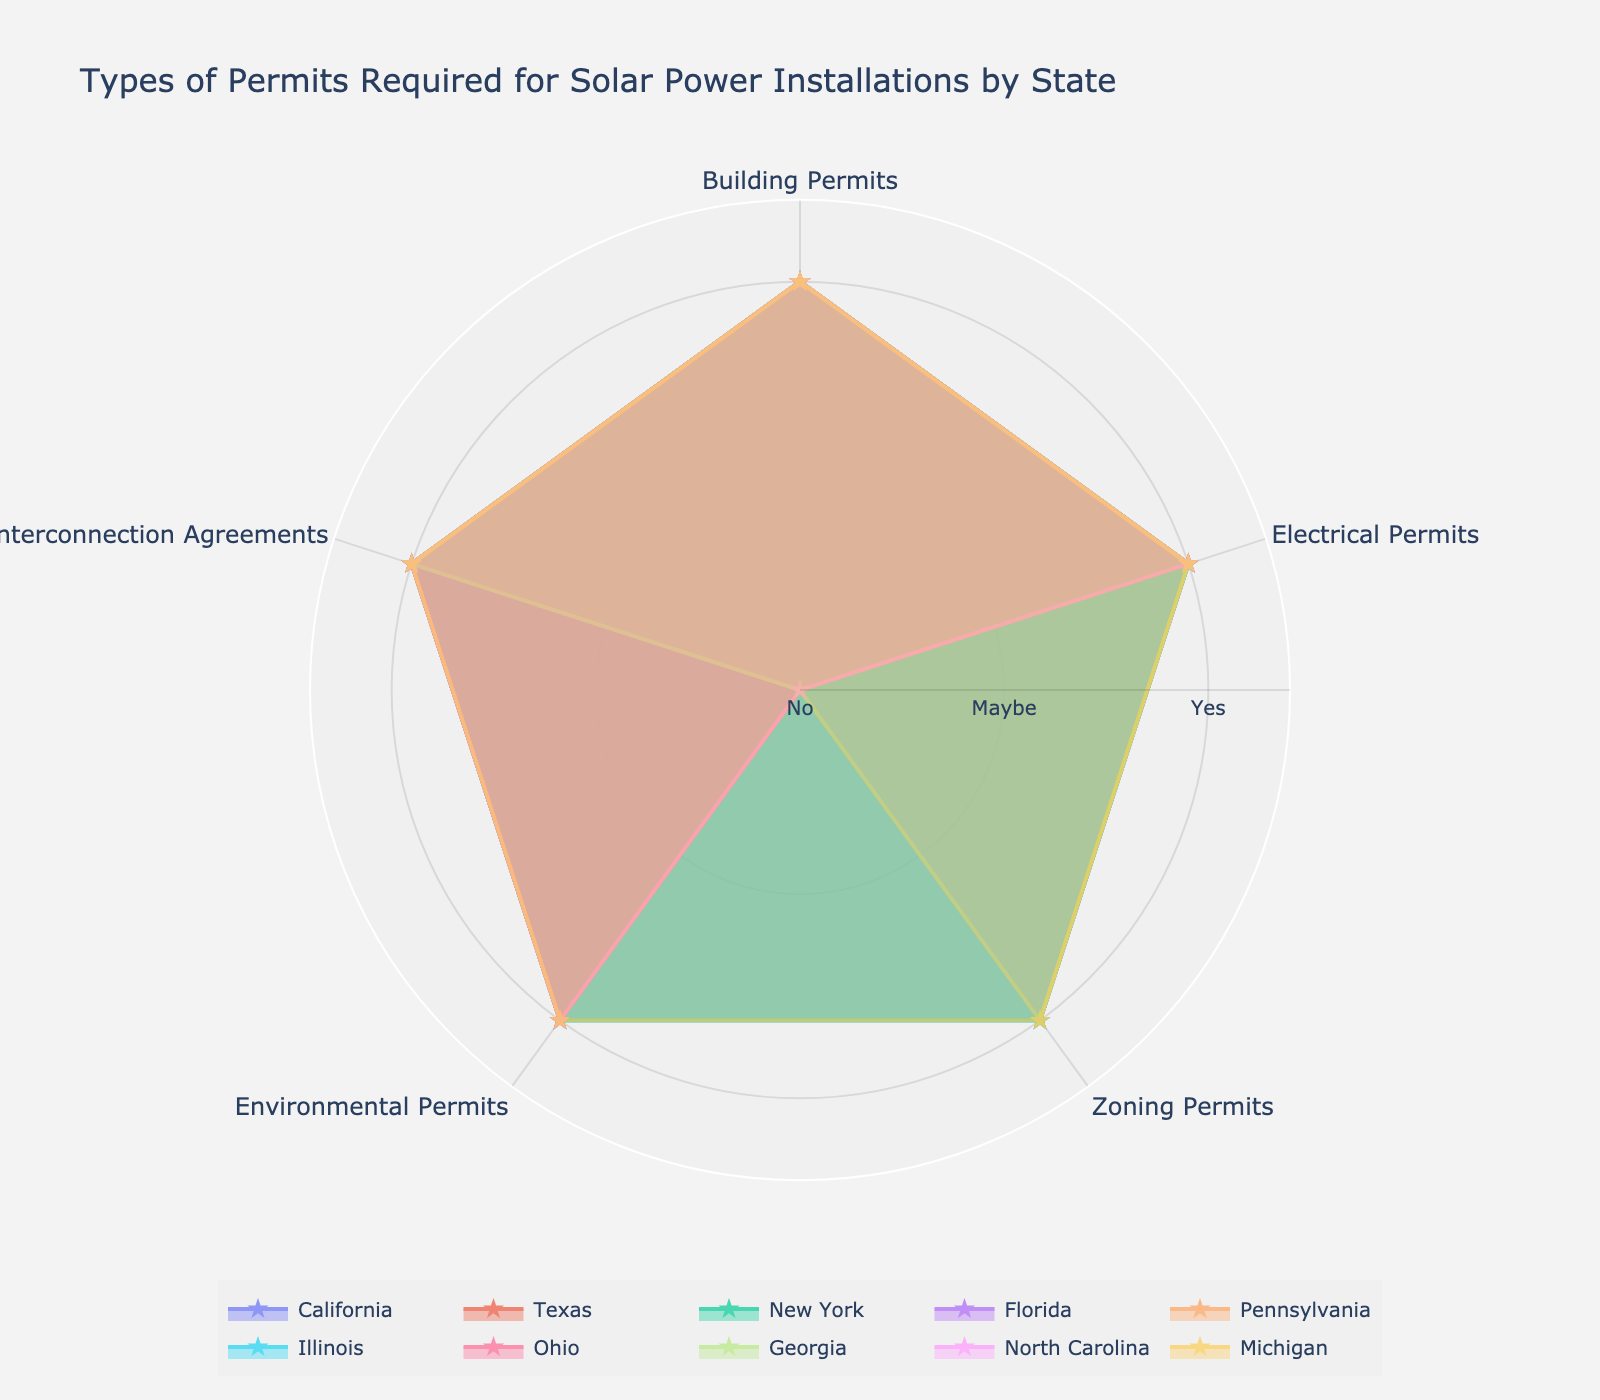What's the title of the chart? The title is the first element of a figure that summarizes what the chart is about, typically found at the top.
Answer: Types of Permits Required for Solar Power Installations by State What color are the grid lines in the chart? Grid lines are the faint lines behind the radar plot that guide the eyes to the data points. They are typically in a distinct but soft color.
Answer: Light gray Which state does not require a Zoning Permit for solar power installations? To determine this, look for states with a 0 value (indicating 'No') in the Zoning Permits portion of the radar chart.
Answer: Texas How many states have all five types of permits required? Identify states that have all entries filled in with a 1 in all five permit categories.
Answer: Six states Which states require Environmental Permits for solar power installations? Find states with a 1 value in the Environmental Permits section of the radar chart.
Answer: California, Texas, New York, Pennsylvania, Illinois, Ohio, North Carolina, Michigan Do any states not require an Interconnection Agreement for solar power installations? Check for any states with a 0 value in the Interconnection Agreements category.
Answer: No, all states require it What is the most common type of permit required by the states listed? For this, identify the permit type that has the highest number of states with a 1 value.
Answer: Electrical Permits Which states do not require Building Permits? Check the radar chart for states with a 0 value in the Building Permits section. (Answer based on provided data)
Answer: All states require Building Permits Compare the environmental permitting requirements between states in the chart and identify any patterns. Find each state's value for Environmental Permits and analyze to find any patterns or similarities.
Answer: California, Texas, New York, Pennsylvania, Illinois, Ohio, North Carolina, and Michigan require it; Florida and Georgia do not What's the percentage of states requiring Zoning Permits for solar power installations? Calculate the total number of states requiring Zoning Permits and divide by the total number of states, then multiply by 100 for the percentage.
Answer: 60% 